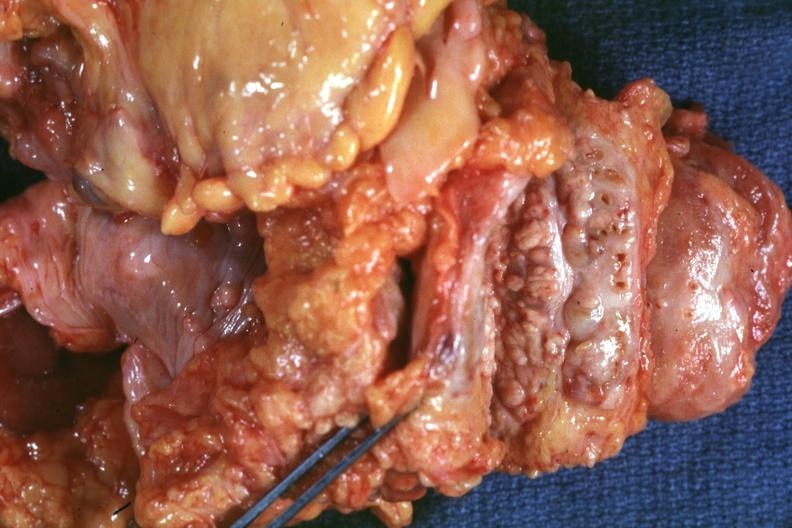does this image show bread-loaf slices into prostate gland photographed close-up showing nodular parenchyma and dense intervening tumor tissue very good?
Answer the question using a single word or phrase. Yes 